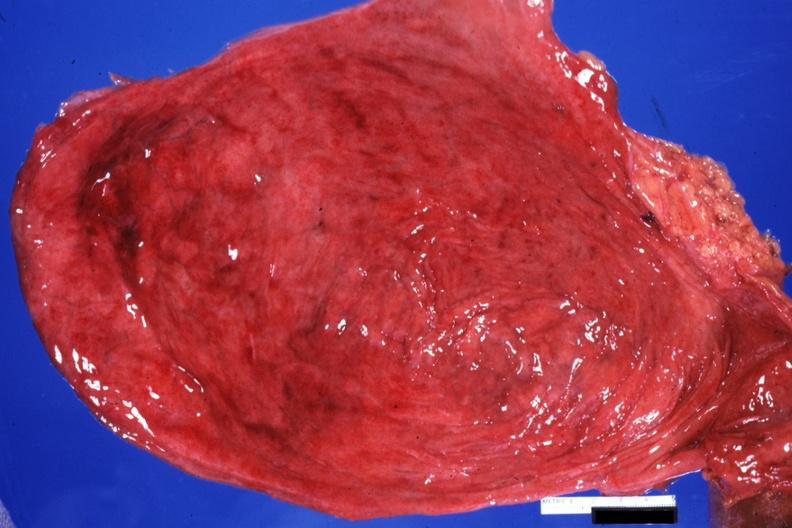s mucicarmine present?
Answer the question using a single word or phrase. No 